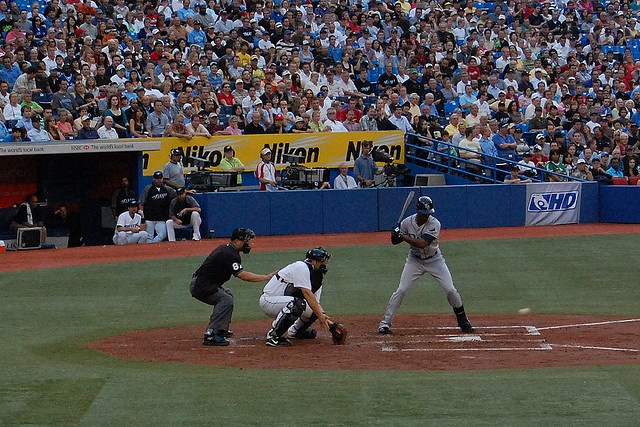Describe the objects in this image and their specific colors. I can see people in navy, black, gray, maroon, and darkgray tones, people in navy, black, gray, and darkgray tones, people in navy, black, gray, maroon, and brown tones, people in navy, gray, and black tones, and people in navy, gray, black, and maroon tones in this image. 